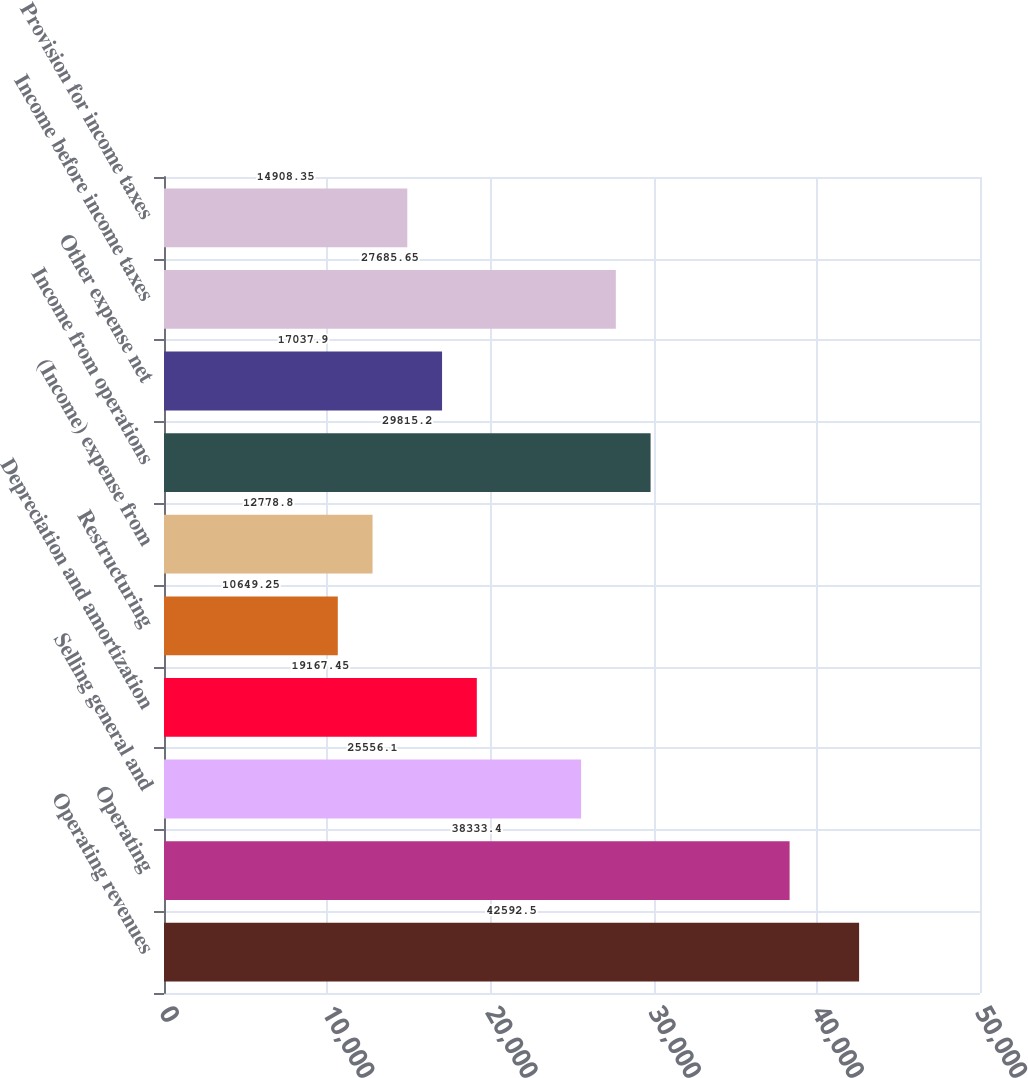Convert chart. <chart><loc_0><loc_0><loc_500><loc_500><bar_chart><fcel>Operating revenues<fcel>Operating<fcel>Selling general and<fcel>Depreciation and amortization<fcel>Restructuring<fcel>(Income) expense from<fcel>Income from operations<fcel>Other expense net<fcel>Income before income taxes<fcel>Provision for income taxes<nl><fcel>42592.5<fcel>38333.4<fcel>25556.1<fcel>19167.5<fcel>10649.2<fcel>12778.8<fcel>29815.2<fcel>17037.9<fcel>27685.7<fcel>14908.4<nl></chart> 